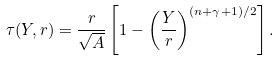Convert formula to latex. <formula><loc_0><loc_0><loc_500><loc_500>\tau ( Y , r ) = \frac { r } { \sqrt { A } } \left [ 1 - \left ( \frac { Y } { r } \right ) ^ { ( n + \gamma + 1 ) / 2 } \right ] .</formula> 